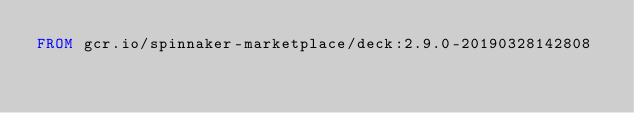<code> <loc_0><loc_0><loc_500><loc_500><_Dockerfile_>FROM gcr.io/spinnaker-marketplace/deck:2.9.0-20190328142808
</code> 